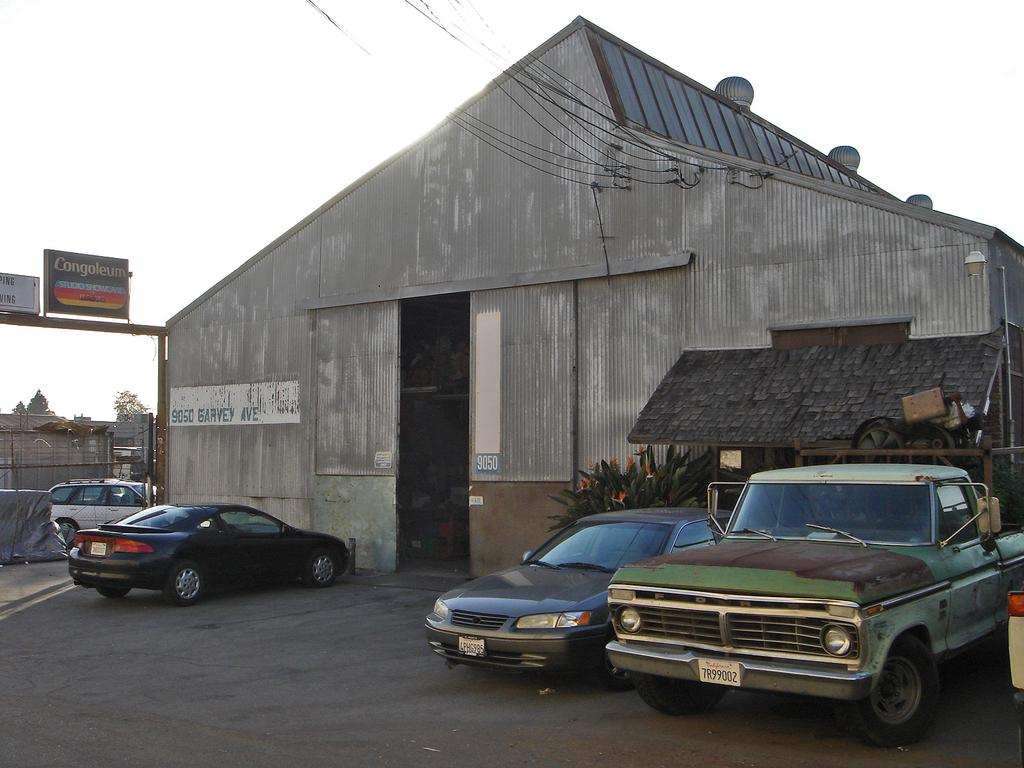What type of structure is present in the image? There is a shed-like structure in the image. What else can be seen around the shed-like structure? There are cars around the shed-like structure. What type of natural elements are present in the image? There are trees in the image. What type of material is visible in the image? There are boards in the image. Can you see a basketball game happening in the image? There is no basketball game present in the image. Is there a thumb visible in the image? There is no thumb visible in the image. 